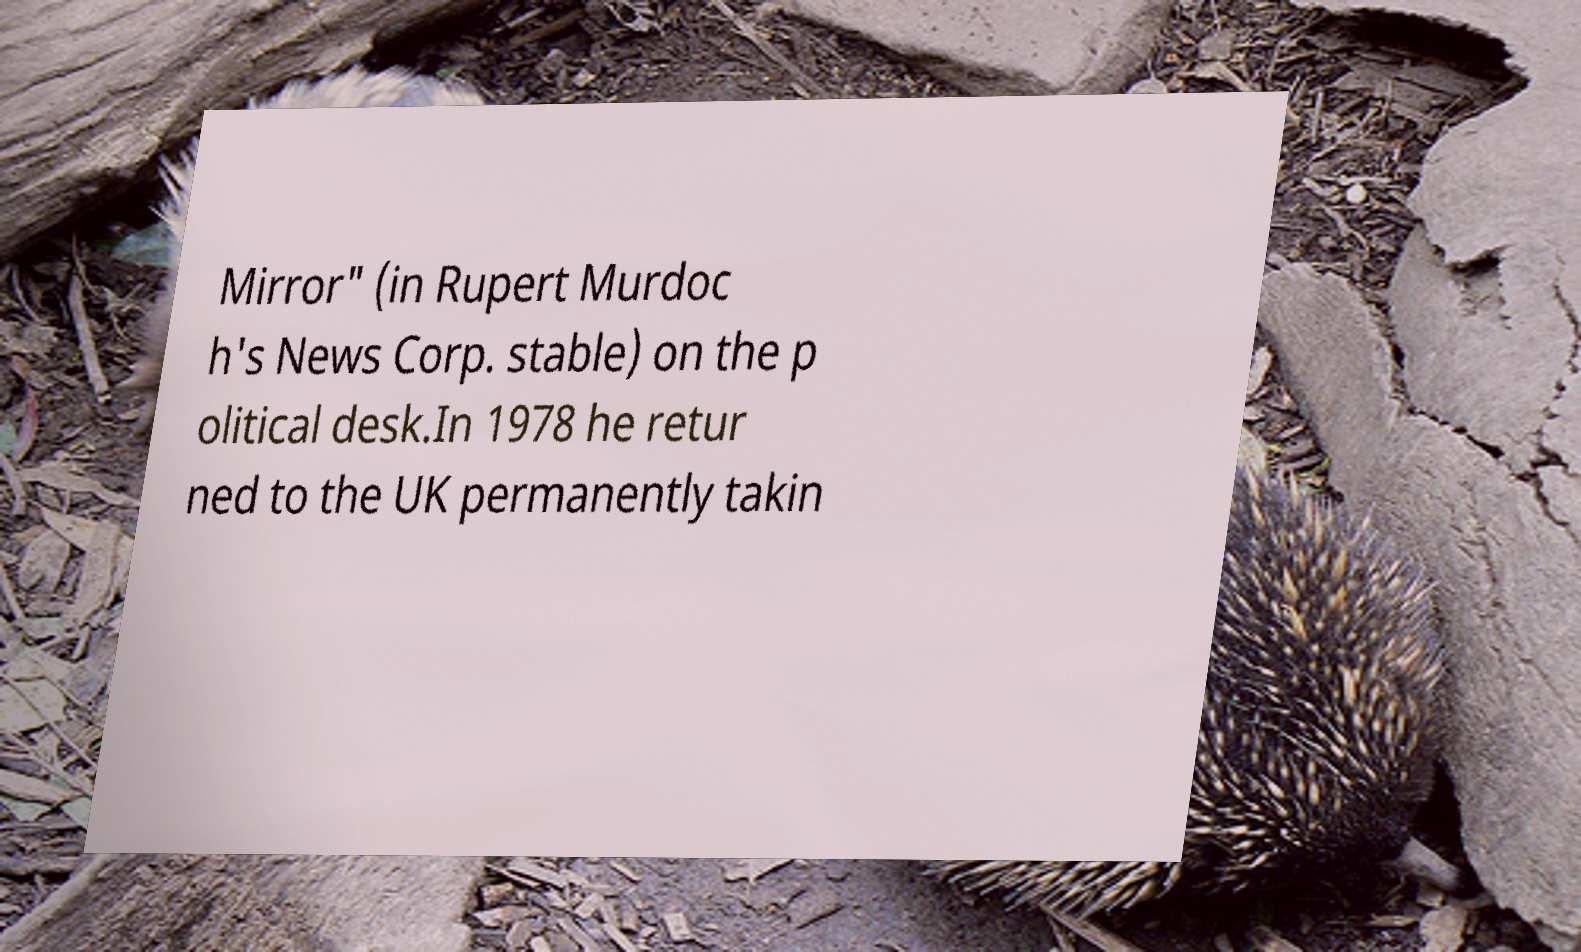Could you assist in decoding the text presented in this image and type it out clearly? Mirror" (in Rupert Murdoc h's News Corp. stable) on the p olitical desk.In 1978 he retur ned to the UK permanently takin 